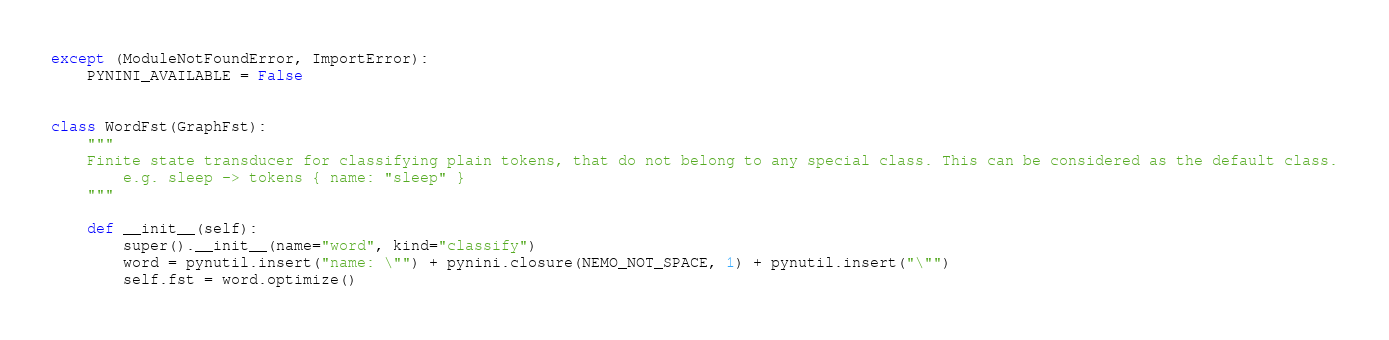<code> <loc_0><loc_0><loc_500><loc_500><_Python_>except (ModuleNotFoundError, ImportError):
    PYNINI_AVAILABLE = False


class WordFst(GraphFst):
    """
    Finite state transducer for classifying plain tokens, that do not belong to any special class. This can be considered as the default class.
        e.g. sleep -> tokens { name: "sleep" }
    """

    def __init__(self):
        super().__init__(name="word", kind="classify")
        word = pynutil.insert("name: \"") + pynini.closure(NEMO_NOT_SPACE, 1) + pynutil.insert("\"")
        self.fst = word.optimize()
</code> 